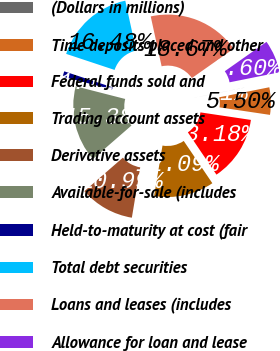Convert chart. <chart><loc_0><loc_0><loc_500><loc_500><pie_chart><fcel>(Dollars in millions)<fcel>Time deposits placed and other<fcel>Federal funds sold and<fcel>Trading account assets<fcel>Derivative assets<fcel>Available-for-sale (includes<fcel>Held-to-maturity at cost (fair<fcel>Total debt securities<fcel>Loans and leases (includes<fcel>Allowance for loan and lease<nl><fcel>0.01%<fcel>5.5%<fcel>13.18%<fcel>12.09%<fcel>10.99%<fcel>15.38%<fcel>1.11%<fcel>16.48%<fcel>18.67%<fcel>6.6%<nl></chart> 